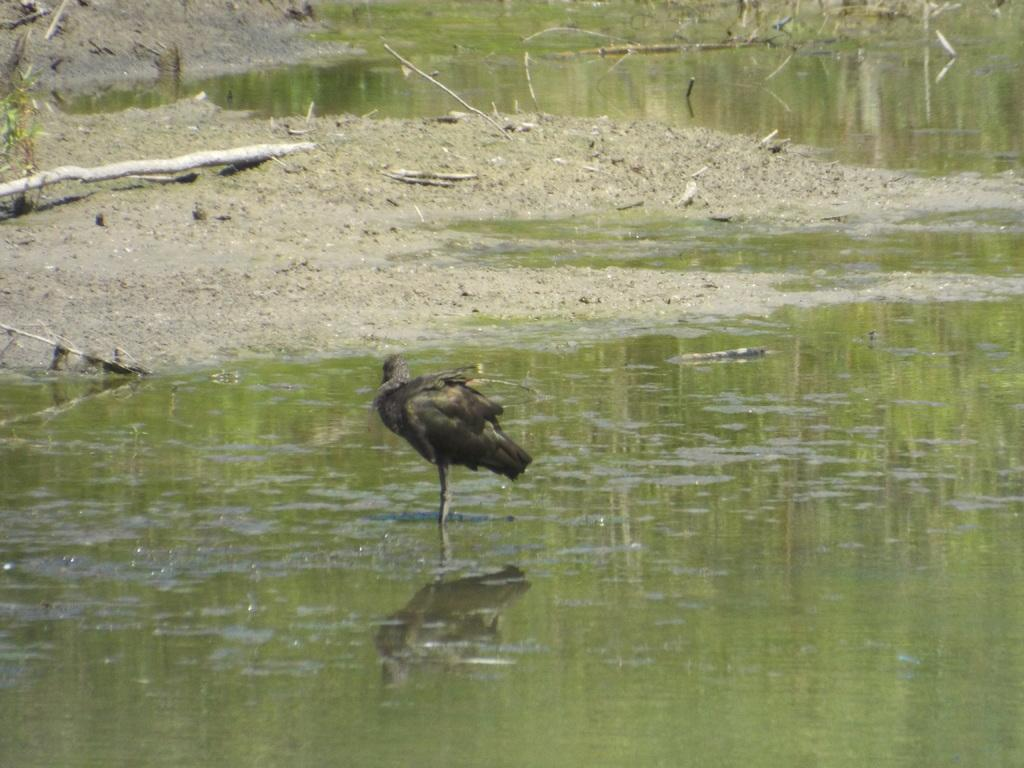What is the main subject of the image? There is a duck in the center of the image. Where is the duck located? The duck is in the water. What can be seen in the background of the image? There is water and mud visible in the background of the image. What type of cable can be seen connecting the duck to the water in the image? There is no cable present in the image; the duck is simply in the water. How many beans are visible in the image? There are no beans present in the image. 